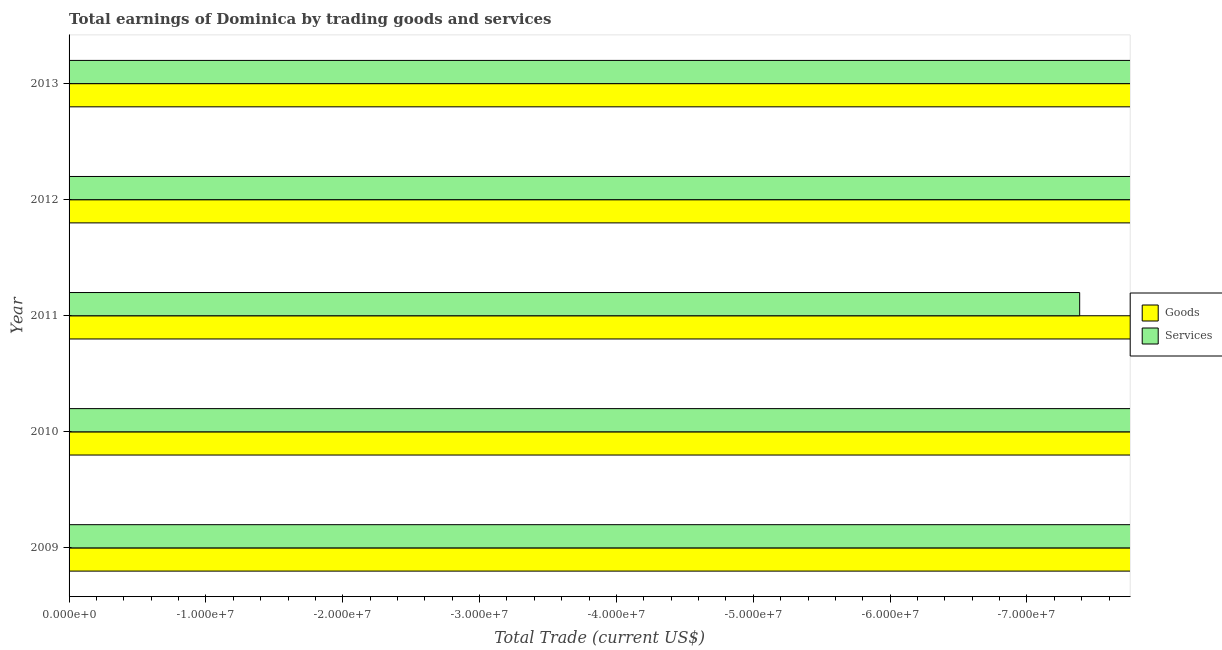How many different coloured bars are there?
Offer a terse response. 0. Are the number of bars per tick equal to the number of legend labels?
Provide a succinct answer. No. Are the number of bars on each tick of the Y-axis equal?
Give a very brief answer. Yes. What is the label of the 1st group of bars from the top?
Ensure brevity in your answer.  2013. What is the amount earned by trading services in 2012?
Offer a very short reply. 0. What is the total amount earned by trading services in the graph?
Ensure brevity in your answer.  0. What is the average amount earned by trading goods per year?
Provide a short and direct response. 0. In how many years, is the amount earned by trading services greater than the average amount earned by trading services taken over all years?
Keep it short and to the point. 0. How many years are there in the graph?
Your answer should be compact. 5. What is the difference between two consecutive major ticks on the X-axis?
Make the answer very short. 1.00e+07. Where does the legend appear in the graph?
Provide a succinct answer. Center right. How are the legend labels stacked?
Provide a short and direct response. Vertical. What is the title of the graph?
Your answer should be very brief. Total earnings of Dominica by trading goods and services. Does "Largest city" appear as one of the legend labels in the graph?
Your response must be concise. No. What is the label or title of the X-axis?
Give a very brief answer. Total Trade (current US$). What is the label or title of the Y-axis?
Provide a succinct answer. Year. What is the Total Trade (current US$) in Services in 2009?
Your response must be concise. 0. What is the Total Trade (current US$) of Services in 2010?
Provide a short and direct response. 0. What is the Total Trade (current US$) in Goods in 2011?
Give a very brief answer. 0. What is the Total Trade (current US$) of Goods in 2012?
Your response must be concise. 0. What is the Total Trade (current US$) in Goods in 2013?
Keep it short and to the point. 0. What is the Total Trade (current US$) in Services in 2013?
Make the answer very short. 0. What is the average Total Trade (current US$) in Services per year?
Offer a terse response. 0. 